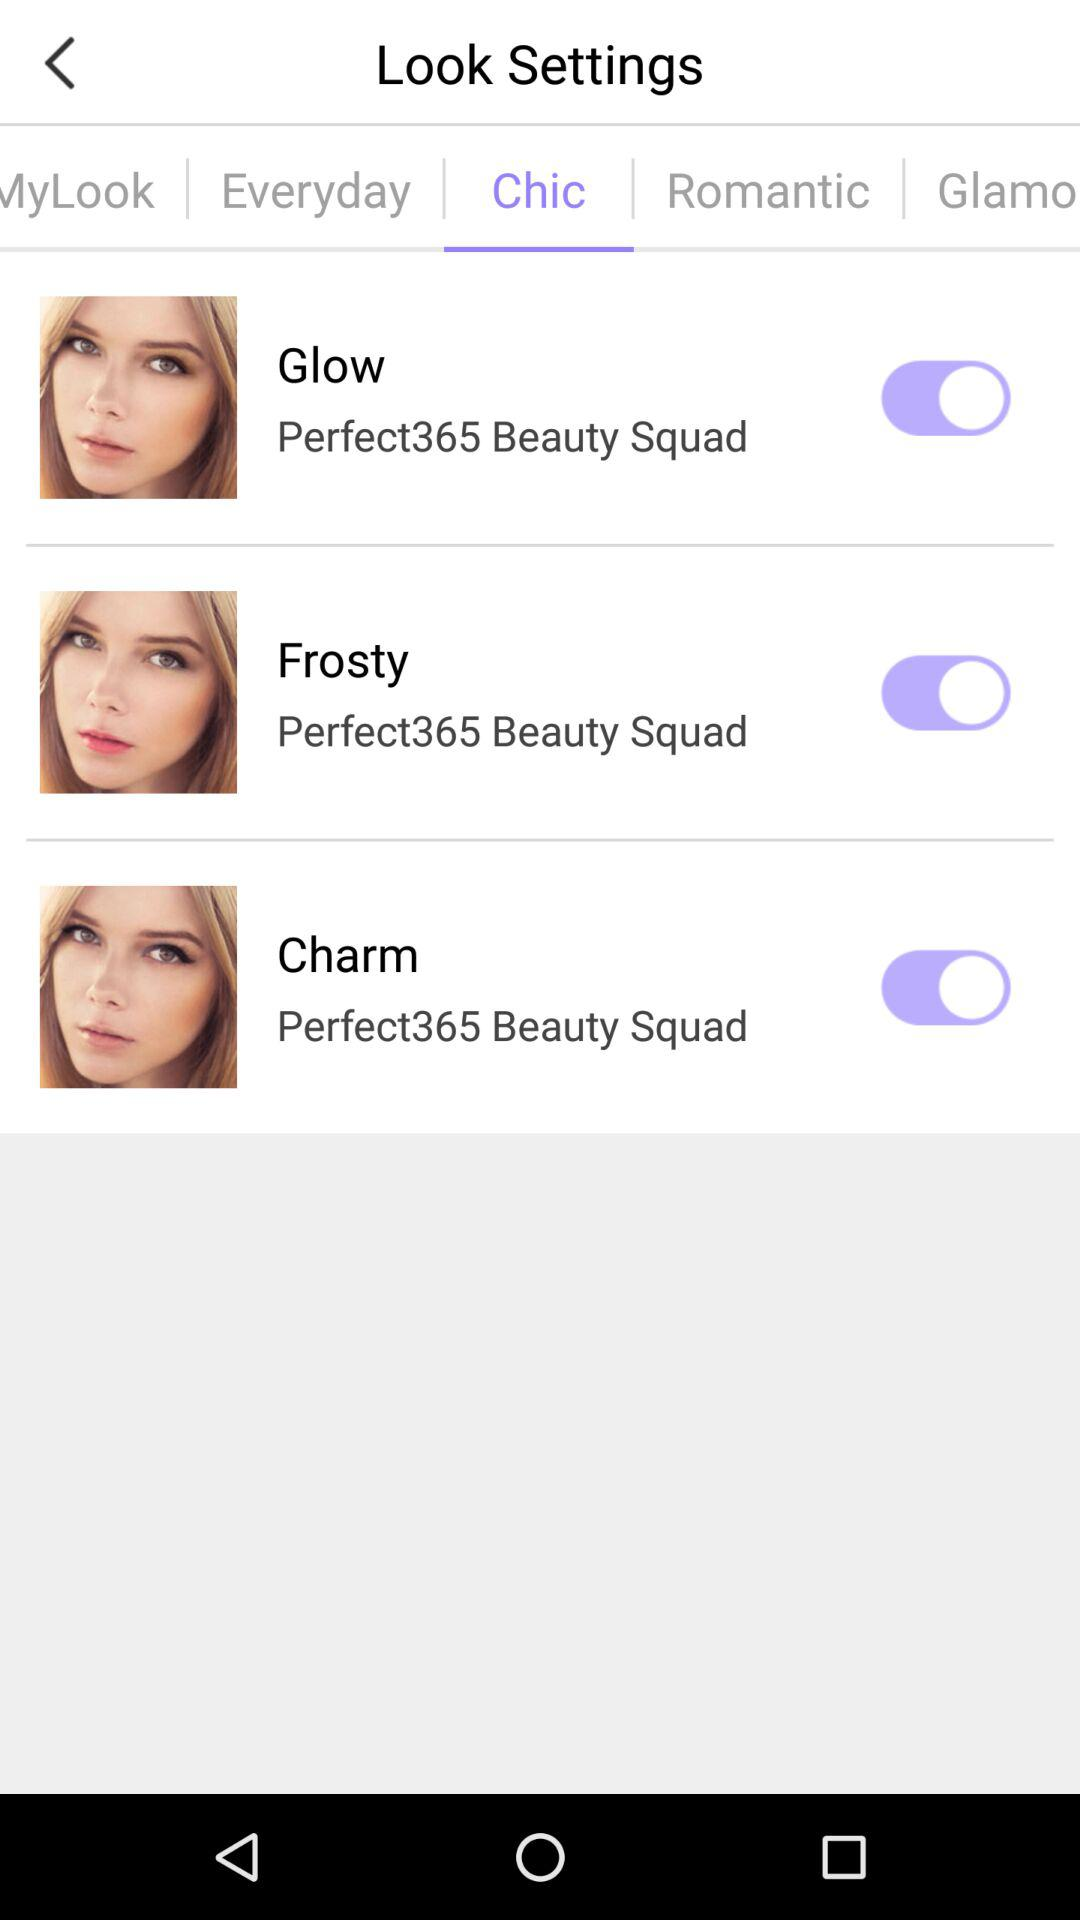How many "Everyday" looks are there?
When the provided information is insufficient, respond with <no answer>. <no answer> 